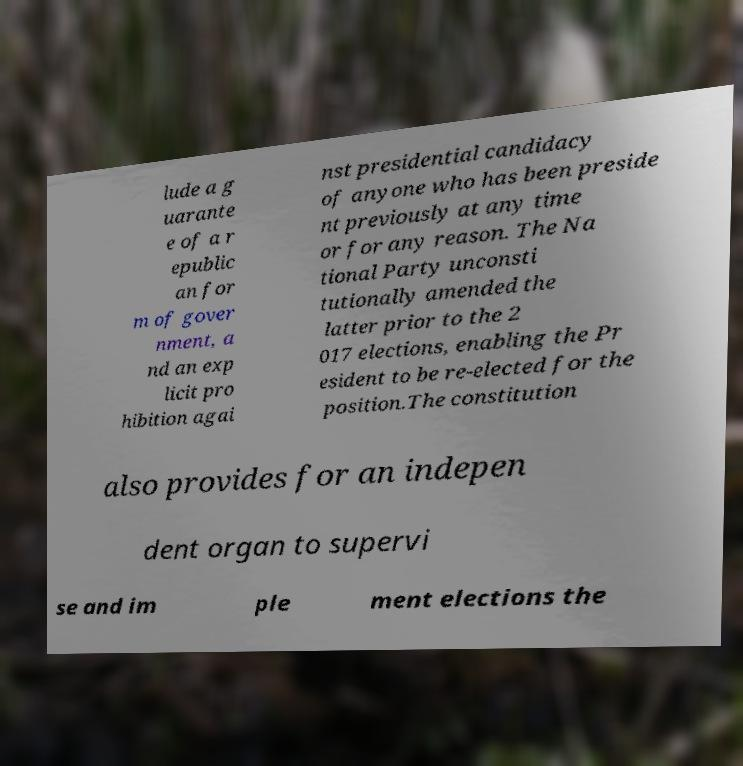There's text embedded in this image that I need extracted. Can you transcribe it verbatim? lude a g uarante e of a r epublic an for m of gover nment, a nd an exp licit pro hibition agai nst presidential candidacy of anyone who has been preside nt previously at any time or for any reason. The Na tional Party unconsti tutionally amended the latter prior to the 2 017 elections, enabling the Pr esident to be re-elected for the position.The constitution also provides for an indepen dent organ to supervi se and im ple ment elections the 